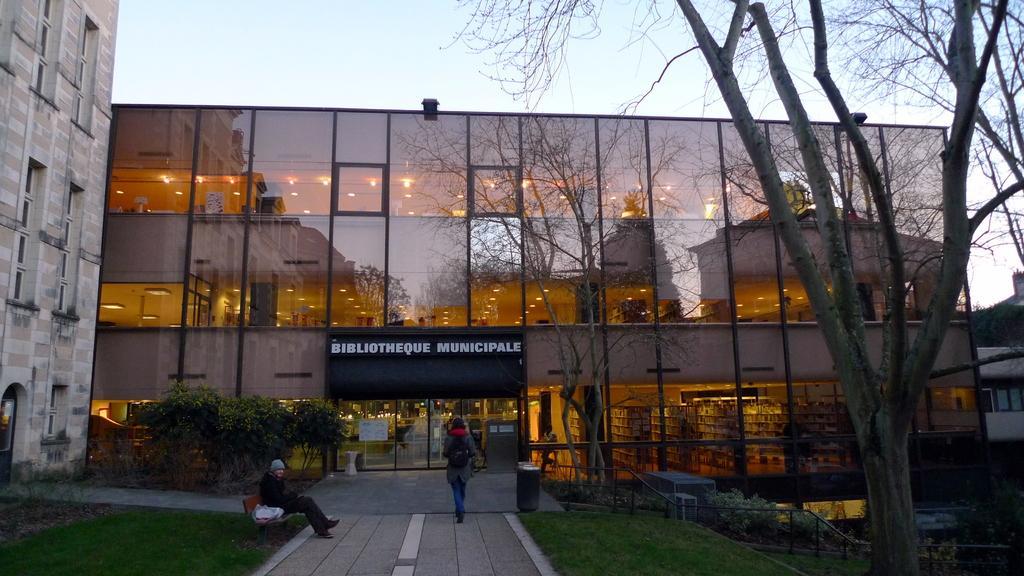Please provide a concise description of this image. In this image I can see the ground, few trees, a person sitting on a bench, a person standing and few buildings. I can see the ceilings of the building and few lights. In the background I can see the sky. 